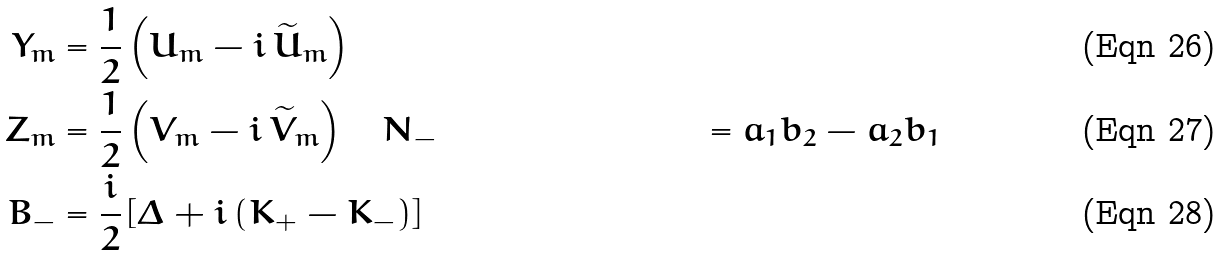<formula> <loc_0><loc_0><loc_500><loc_500>Y _ { m } & = \frac { 1 } { 2 } \left ( U _ { m } - i \, \widetilde { U } _ { m } \right ) \\ Z _ { m } & = \frac { 1 } { 2 } \left ( V _ { m } - i \, \widetilde { V } _ { m } \right ) \quad N _ { - } & = a _ { 1 } b _ { 2 } - a _ { 2 } b _ { 1 } \\ B _ { - } & = \frac { i } { 2 } \left [ \Delta + i \left ( K _ { + } - K _ { - } \right ) \right ]</formula> 